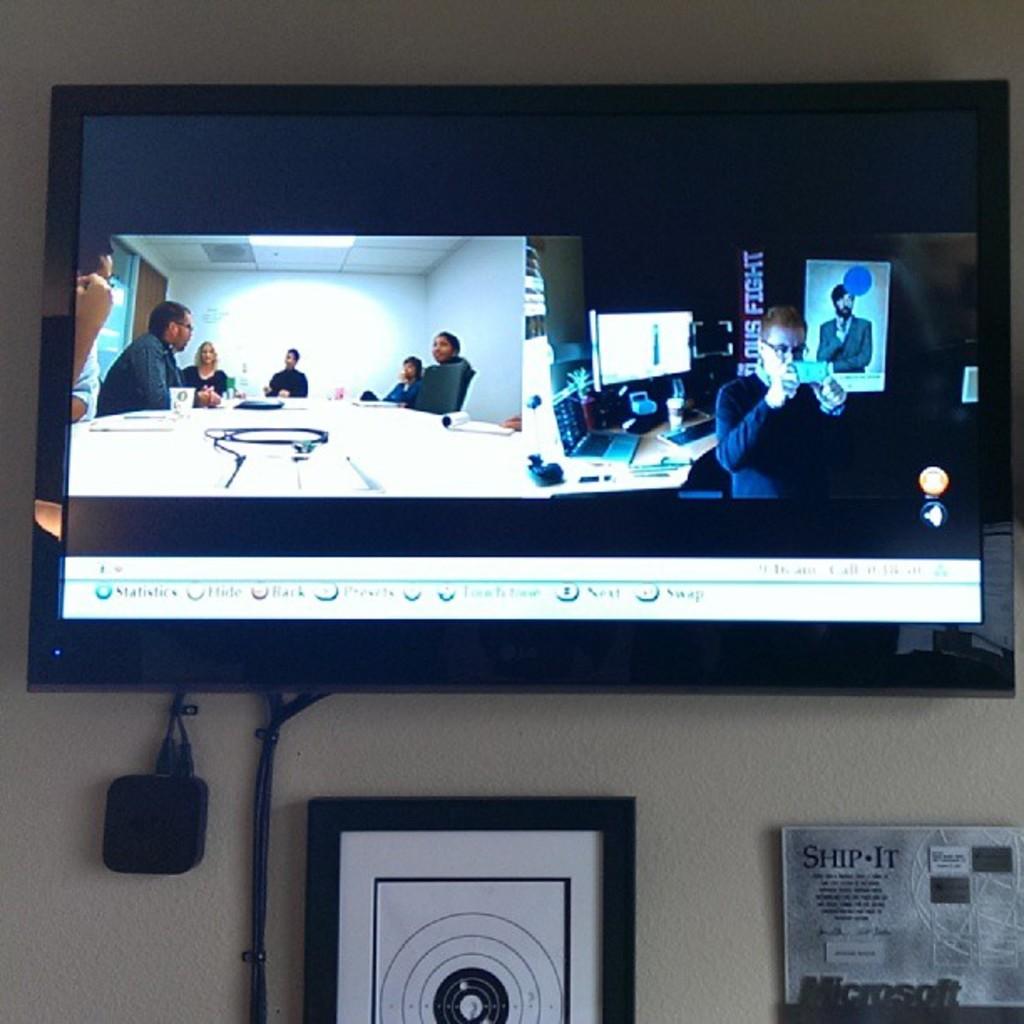What large technology company is shown to the right of the bullseye?
Keep it short and to the point. Microsoft. 